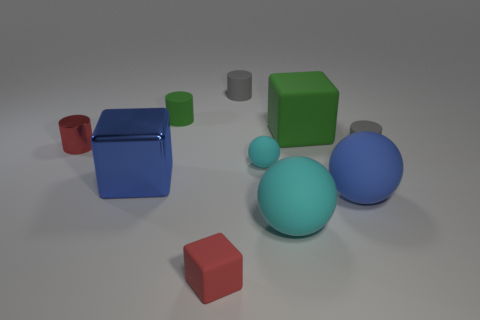There is a matte object that is the same color as the tiny sphere; what is its size?
Your response must be concise. Large. There is a thing that is the same color as the large shiny block; what is its shape?
Offer a terse response. Sphere. Is the red metallic thing the same size as the blue metallic object?
Offer a very short reply. No. How many objects are either cyan matte objects or blue metal cubes that are on the left side of the large cyan thing?
Keep it short and to the point. 3. There is a large cube to the right of the cyan ball behind the blue metal object; what is its color?
Provide a succinct answer. Green. Do the block that is on the left side of the red cube and the small sphere have the same color?
Ensure brevity in your answer.  No. There is a green object that is on the left side of the small red matte thing; what is it made of?
Offer a very short reply. Rubber. How big is the red matte block?
Provide a succinct answer. Small. Are the gray cylinder that is behind the metal cylinder and the large green thing made of the same material?
Offer a terse response. Yes. How many small red rubber blocks are there?
Offer a very short reply. 1. 